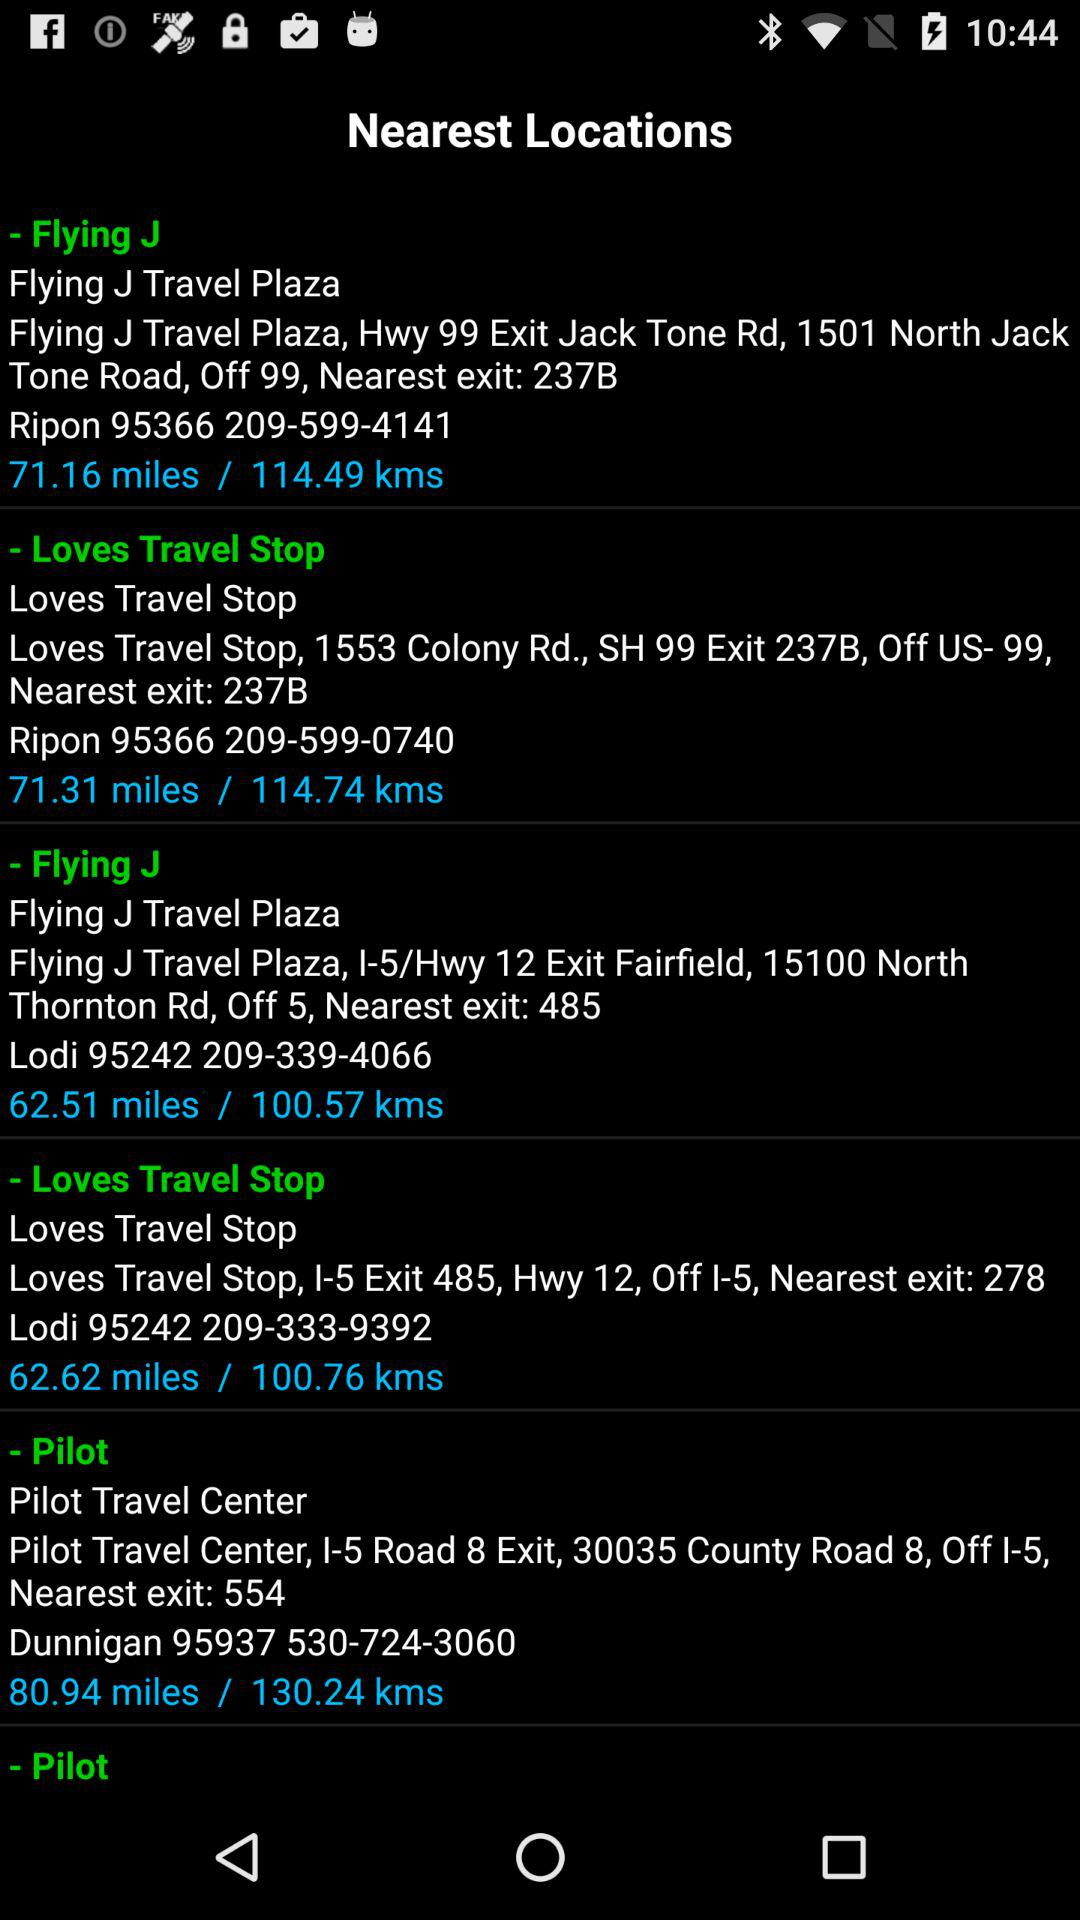What is the nearest exit of the "Flying J" which is 71.16 miles away? The nearest exit is 237B. 